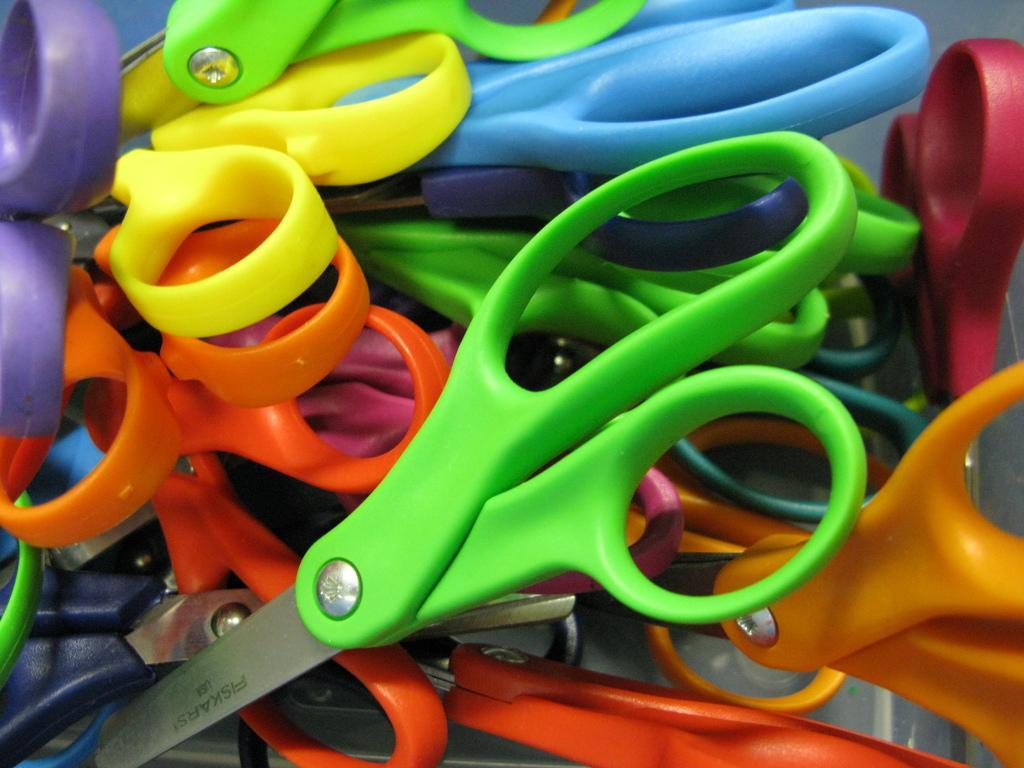Describe this image in one or two sentences. In this image there are many scissors. They have colorful holders. 